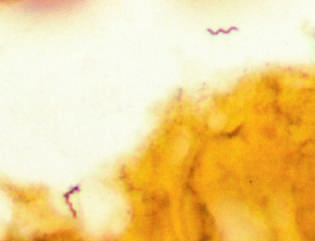s this silver stain preparation of brain tissue from a patient with lyme disease meningoencephalitis?
Answer the question using a single word or phrase. Yes 